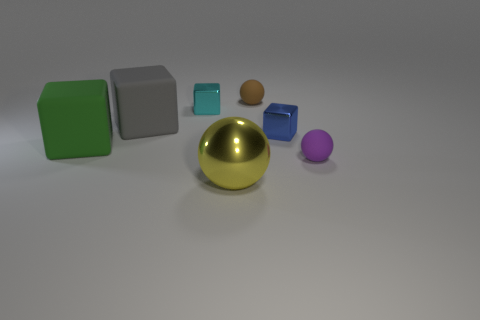Subtract 1 blocks. How many blocks are left? 3 Add 1 tiny gray metal things. How many objects exist? 8 Subtract all spheres. How many objects are left? 4 Add 5 big red cubes. How many big red cubes exist? 5 Subtract 0 brown cubes. How many objects are left? 7 Subtract all cyan things. Subtract all small blue metallic objects. How many objects are left? 5 Add 1 gray matte blocks. How many gray matte blocks are left? 2 